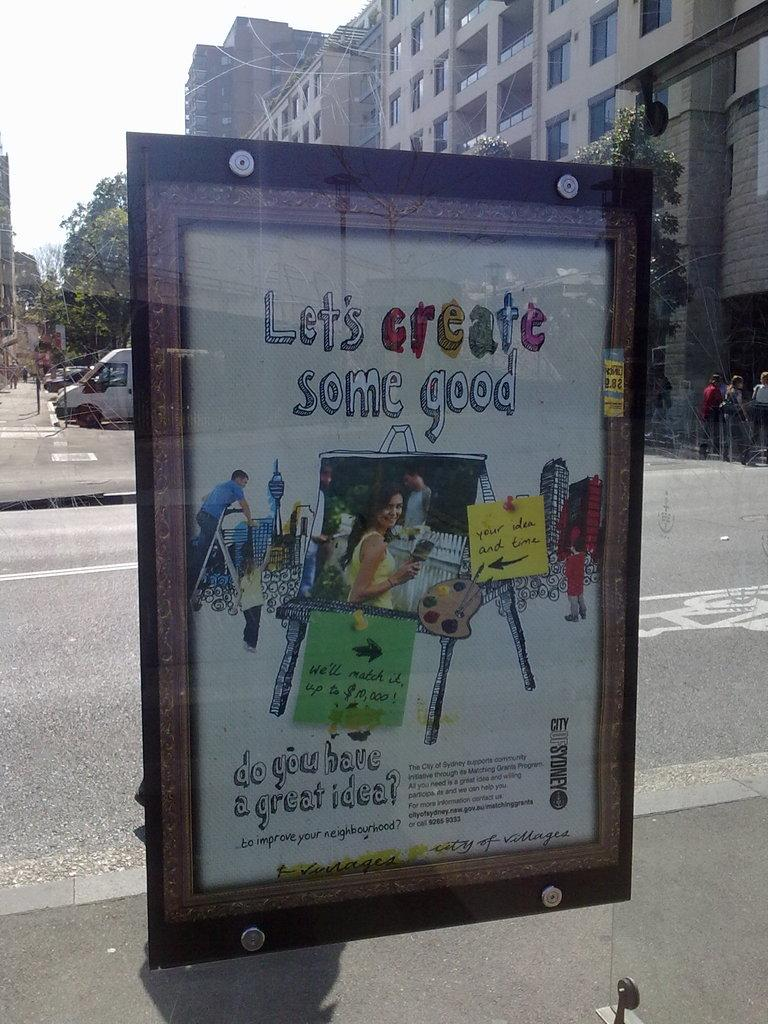<image>
Summarize the visual content of the image. An outdoor billboard that reads let's create some good. 